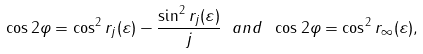<formula> <loc_0><loc_0><loc_500><loc_500>\cos 2 \varphi = \cos ^ { 2 } r _ { j } ( \varepsilon ) - \frac { \sin ^ { 2 } r _ { j } ( \varepsilon ) } { j } \ a n d \ \cos 2 \varphi = \cos ^ { 2 } r _ { \infty } ( \varepsilon ) ,</formula> 